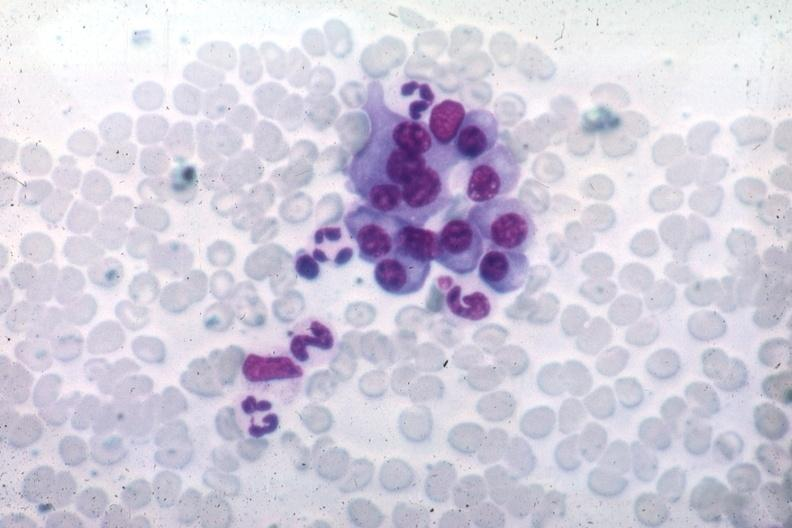s malignant lymphoma present?
Answer the question using a single word or phrase. No 